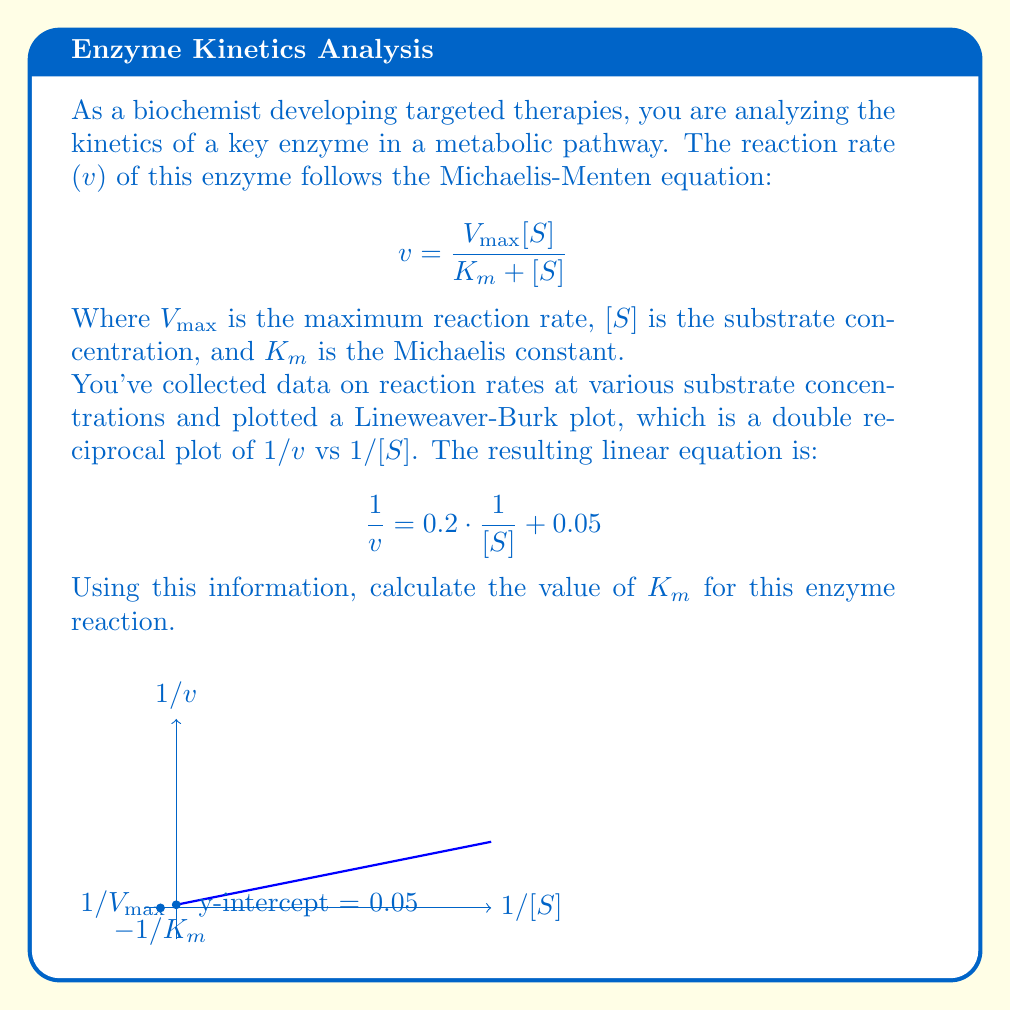Show me your answer to this math problem. Let's approach this step-by-step:

1) The Lineweaver-Burk plot is a linear transformation of the Michaelis-Menten equation. It takes the form:

   $$ \frac{1}{v} = \frac{K_m}{V_{max}} \cdot \frac{1}{[S]} + \frac{1}{V_{max}} $$

2) Comparing this to the given equation:

   $$ \frac{1}{v} = 0.2 \cdot \frac{1}{[S]} + 0.05 $$

   We can identify that:
   
   $\frac{K_m}{V_{max}} = 0.2$ and $\frac{1}{V_{max}} = 0.05$

3) From $\frac{1}{V_{max}} = 0.05$, we can calculate $V_{max}$:

   $V_{max} = \frac{1}{0.05} = 20$

4) Now, we can use the relation $\frac{K_m}{V_{max}} = 0.2$ to find $K_m$:

   $K_m = 0.2 \cdot V_{max} = 0.2 \cdot 20 = 4$

Therefore, the Michaelis constant $K_m$ for this enzyme reaction is 4.
Answer: $K_m = 4$ 